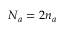<formula> <loc_0><loc_0><loc_500><loc_500>N _ { a } = 2 n _ { a }</formula> 